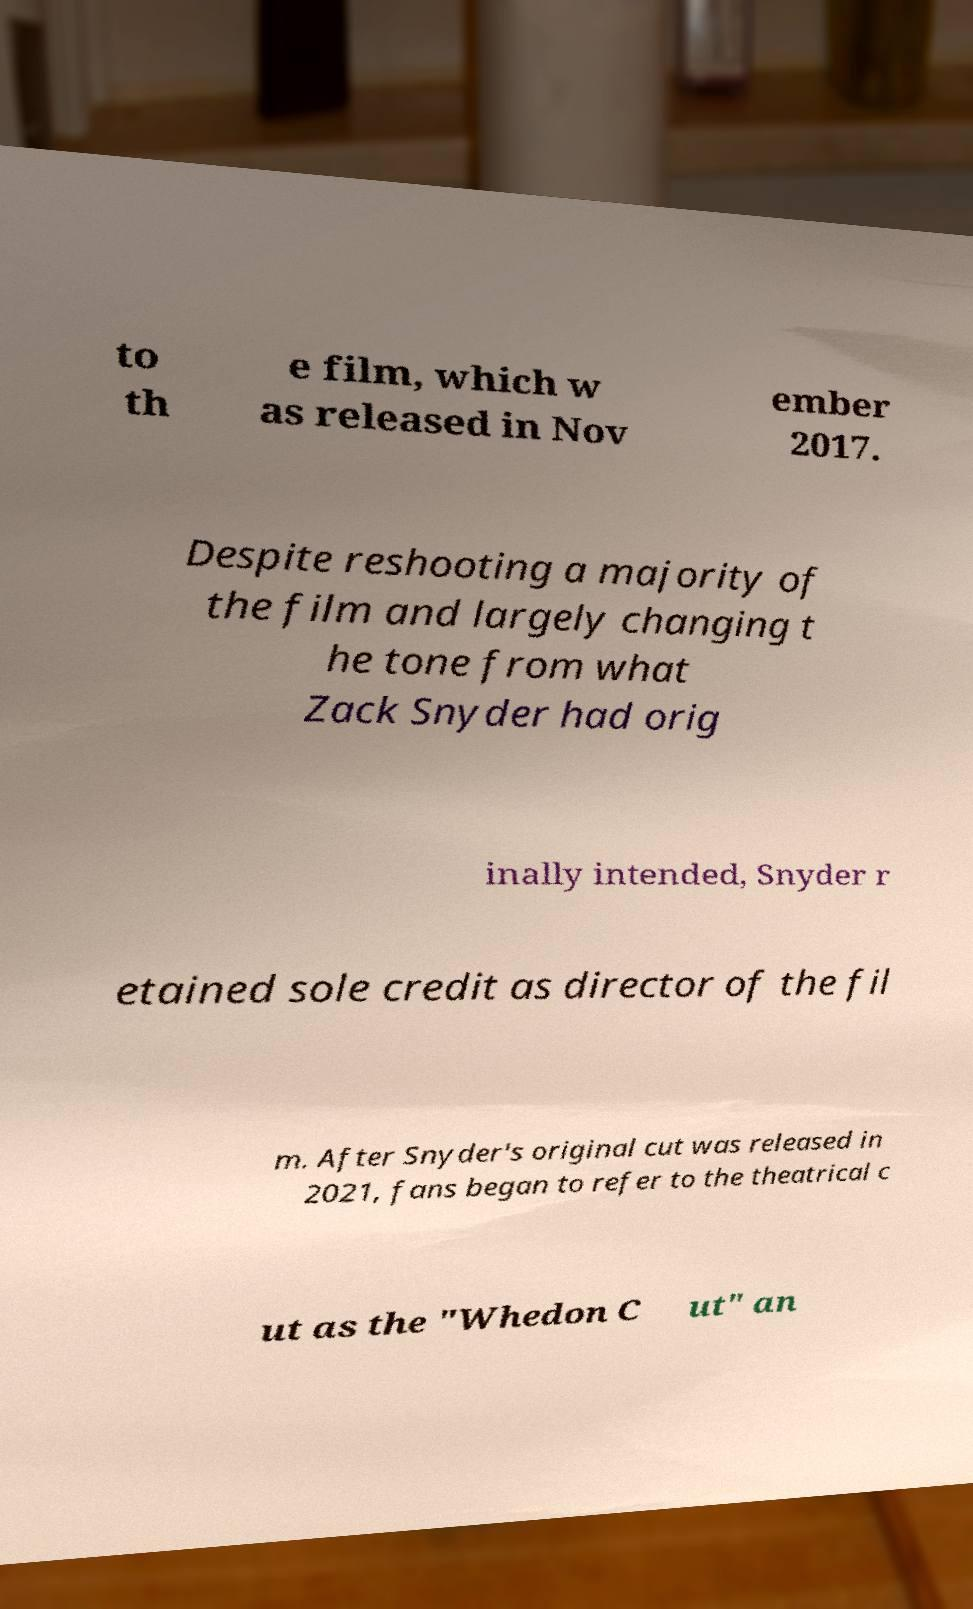Can you accurately transcribe the text from the provided image for me? to th e film, which w as released in Nov ember 2017. Despite reshooting a majority of the film and largely changing t he tone from what Zack Snyder had orig inally intended, Snyder r etained sole credit as director of the fil m. After Snyder's original cut was released in 2021, fans began to refer to the theatrical c ut as the "Whedon C ut" an 